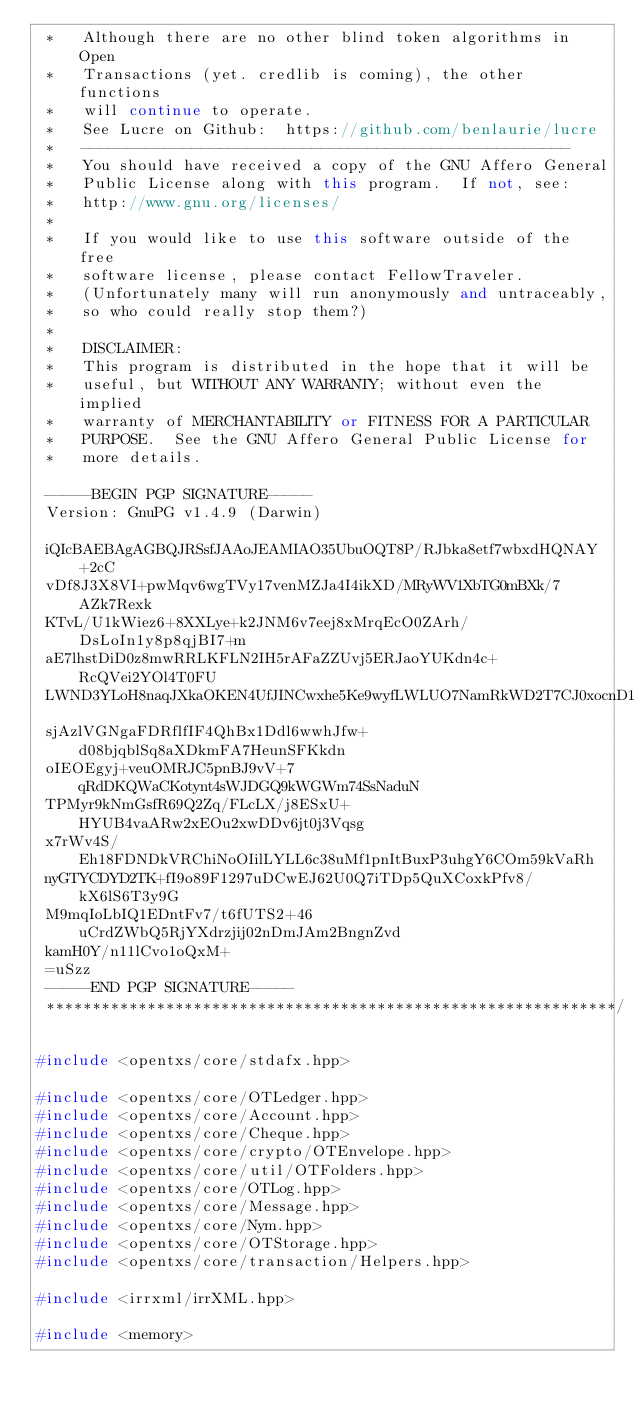Convert code to text. <code><loc_0><loc_0><loc_500><loc_500><_C++_> *   Although there are no other blind token algorithms in Open
 *   Transactions (yet. credlib is coming), the other functions
 *   will continue to operate.
 *   See Lucre on Github:  https://github.com/benlaurie/lucre
 *   -----------------------------------------------------
 *   You should have received a copy of the GNU Affero General
 *   Public License along with this program.  If not, see:
 *   http://www.gnu.org/licenses/
 *
 *   If you would like to use this software outside of the free
 *   software license, please contact FellowTraveler.
 *   (Unfortunately many will run anonymously and untraceably,
 *   so who could really stop them?)
 *
 *   DISCLAIMER:
 *   This program is distributed in the hope that it will be
 *   useful, but WITHOUT ANY WARRANTY; without even the implied
 *   warranty of MERCHANTABILITY or FITNESS FOR A PARTICULAR
 *   PURPOSE.  See the GNU Affero General Public License for
 *   more details.

 -----BEGIN PGP SIGNATURE-----
 Version: GnuPG v1.4.9 (Darwin)

 iQIcBAEBAgAGBQJRSsfJAAoJEAMIAO35UbuOQT8P/RJbka8etf7wbxdHQNAY+2cC
 vDf8J3X8VI+pwMqv6wgTVy17venMZJa4I4ikXD/MRyWV1XbTG0mBXk/7AZk7Rexk
 KTvL/U1kWiez6+8XXLye+k2JNM6v7eej8xMrqEcO0ZArh/DsLoIn1y8p8qjBI7+m
 aE7lhstDiD0z8mwRRLKFLN2IH5rAFaZZUvj5ERJaoYUKdn4c+RcQVei2YOl4T0FU
 LWND3YLoH8naqJXkaOKEN4UfJINCwxhe5Ke9wyfLWLUO7NamRkWD2T7CJ0xocnD1
 sjAzlVGNgaFDRflfIF4QhBx1Ddl6wwhJfw+d08bjqblSq8aXDkmFA7HeunSFKkdn
 oIEOEgyj+veuOMRJC5pnBJ9vV+7qRdDKQWaCKotynt4sWJDGQ9kWGWm74SsNaduN
 TPMyr9kNmGsfR69Q2Zq/FLcLX/j8ESxU+HYUB4vaARw2xEOu2xwDDv6jt0j3Vqsg
 x7rWv4S/Eh18FDNDkVRChiNoOIilLYLL6c38uMf1pnItBuxP3uhgY6COm59kVaRh
 nyGTYCDYD2TK+fI9o89F1297uDCwEJ62U0Q7iTDp5QuXCoxkPfv8/kX6lS6T3y9G
 M9mqIoLbIQ1EDntFv7/t6fUTS2+46uCrdZWbQ5RjYXdrzjij02nDmJAm2BngnZvd
 kamH0Y/n11lCvo1oQxM+
 =uSzz
 -----END PGP SIGNATURE-----
 **************************************************************/

#include <opentxs/core/stdafx.hpp>

#include <opentxs/core/OTLedger.hpp>
#include <opentxs/core/Account.hpp>
#include <opentxs/core/Cheque.hpp>
#include <opentxs/core/crypto/OTEnvelope.hpp>
#include <opentxs/core/util/OTFolders.hpp>
#include <opentxs/core/OTLog.hpp>
#include <opentxs/core/Message.hpp>
#include <opentxs/core/Nym.hpp>
#include <opentxs/core/OTStorage.hpp>
#include <opentxs/core/transaction/Helpers.hpp>

#include <irrxml/irrXML.hpp>

#include <memory>
</code> 